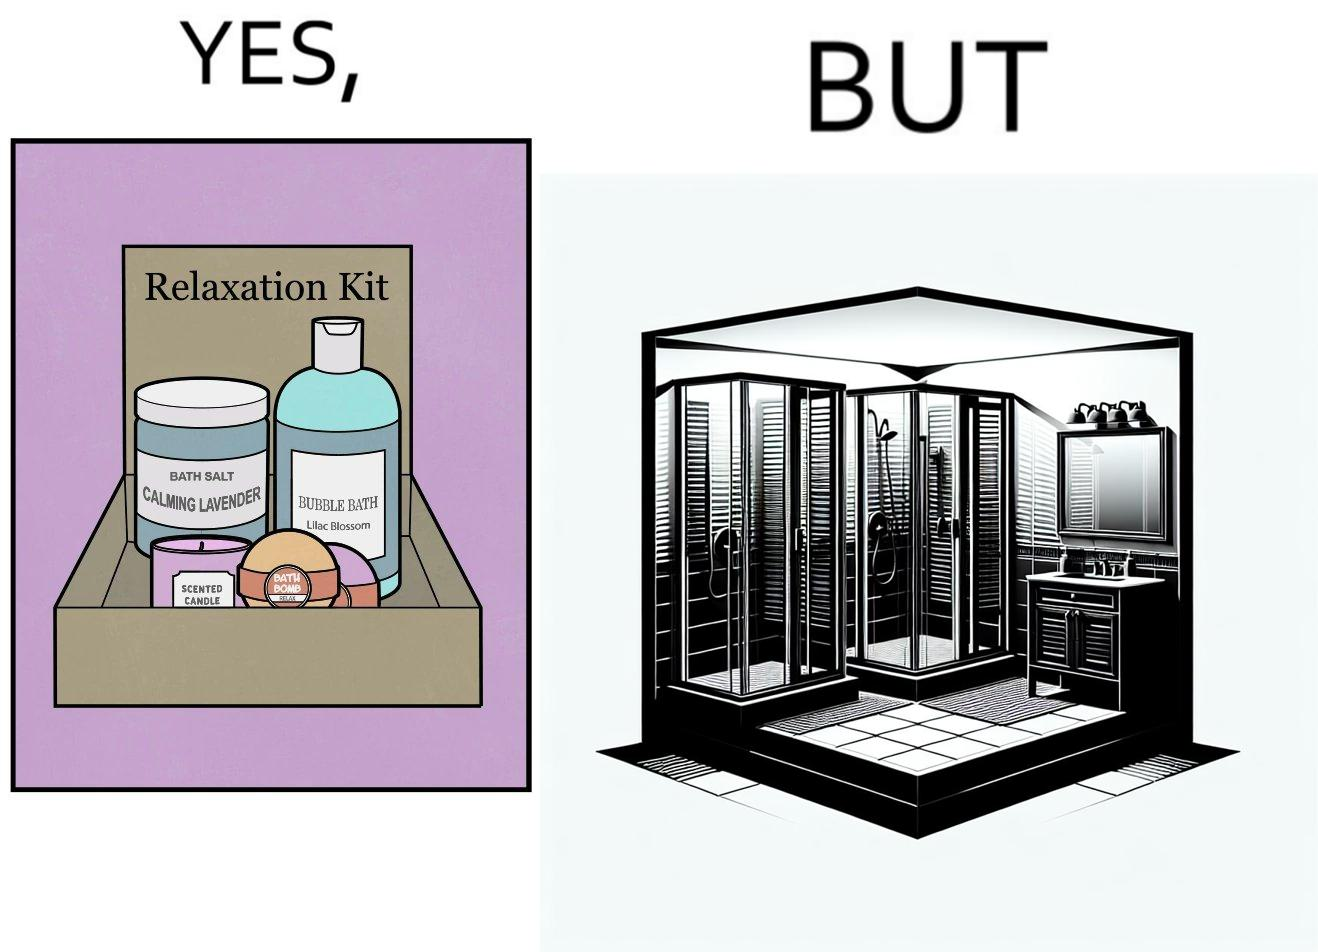Describe the satirical element in this image. The image is ironical, as the relaxation kit is meant to relax and calm down the person using it during a bath, but the showering area is an enclosed space, which might instead tense up someone, especially if the person is claustrophobic. 